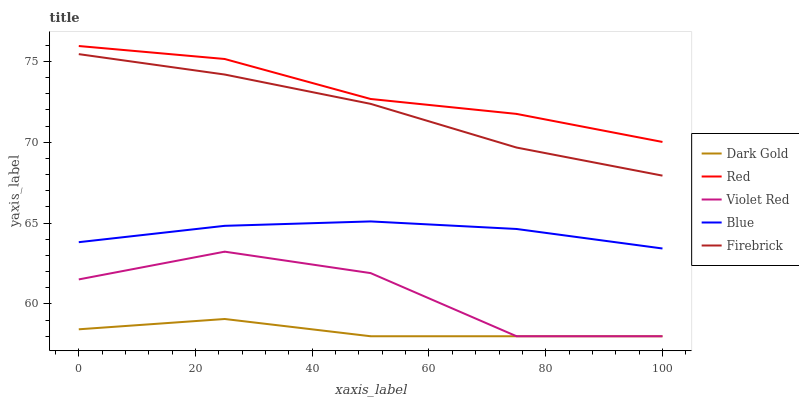Does Dark Gold have the minimum area under the curve?
Answer yes or no. Yes. Does Red have the maximum area under the curve?
Answer yes or no. Yes. Does Violet Red have the minimum area under the curve?
Answer yes or no. No. Does Violet Red have the maximum area under the curve?
Answer yes or no. No. Is Blue the smoothest?
Answer yes or no. Yes. Is Violet Red the roughest?
Answer yes or no. Yes. Is Firebrick the smoothest?
Answer yes or no. No. Is Firebrick the roughest?
Answer yes or no. No. Does Violet Red have the lowest value?
Answer yes or no. Yes. Does Firebrick have the lowest value?
Answer yes or no. No. Does Red have the highest value?
Answer yes or no. Yes. Does Violet Red have the highest value?
Answer yes or no. No. Is Dark Gold less than Blue?
Answer yes or no. Yes. Is Red greater than Violet Red?
Answer yes or no. Yes. Does Violet Red intersect Dark Gold?
Answer yes or no. Yes. Is Violet Red less than Dark Gold?
Answer yes or no. No. Is Violet Red greater than Dark Gold?
Answer yes or no. No. Does Dark Gold intersect Blue?
Answer yes or no. No. 